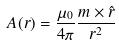Convert formula to latex. <formula><loc_0><loc_0><loc_500><loc_500>A ( r ) = \frac { \mu _ { 0 } } { 4 \pi } \frac { m \times \hat { r } } { r ^ { 2 } }</formula> 